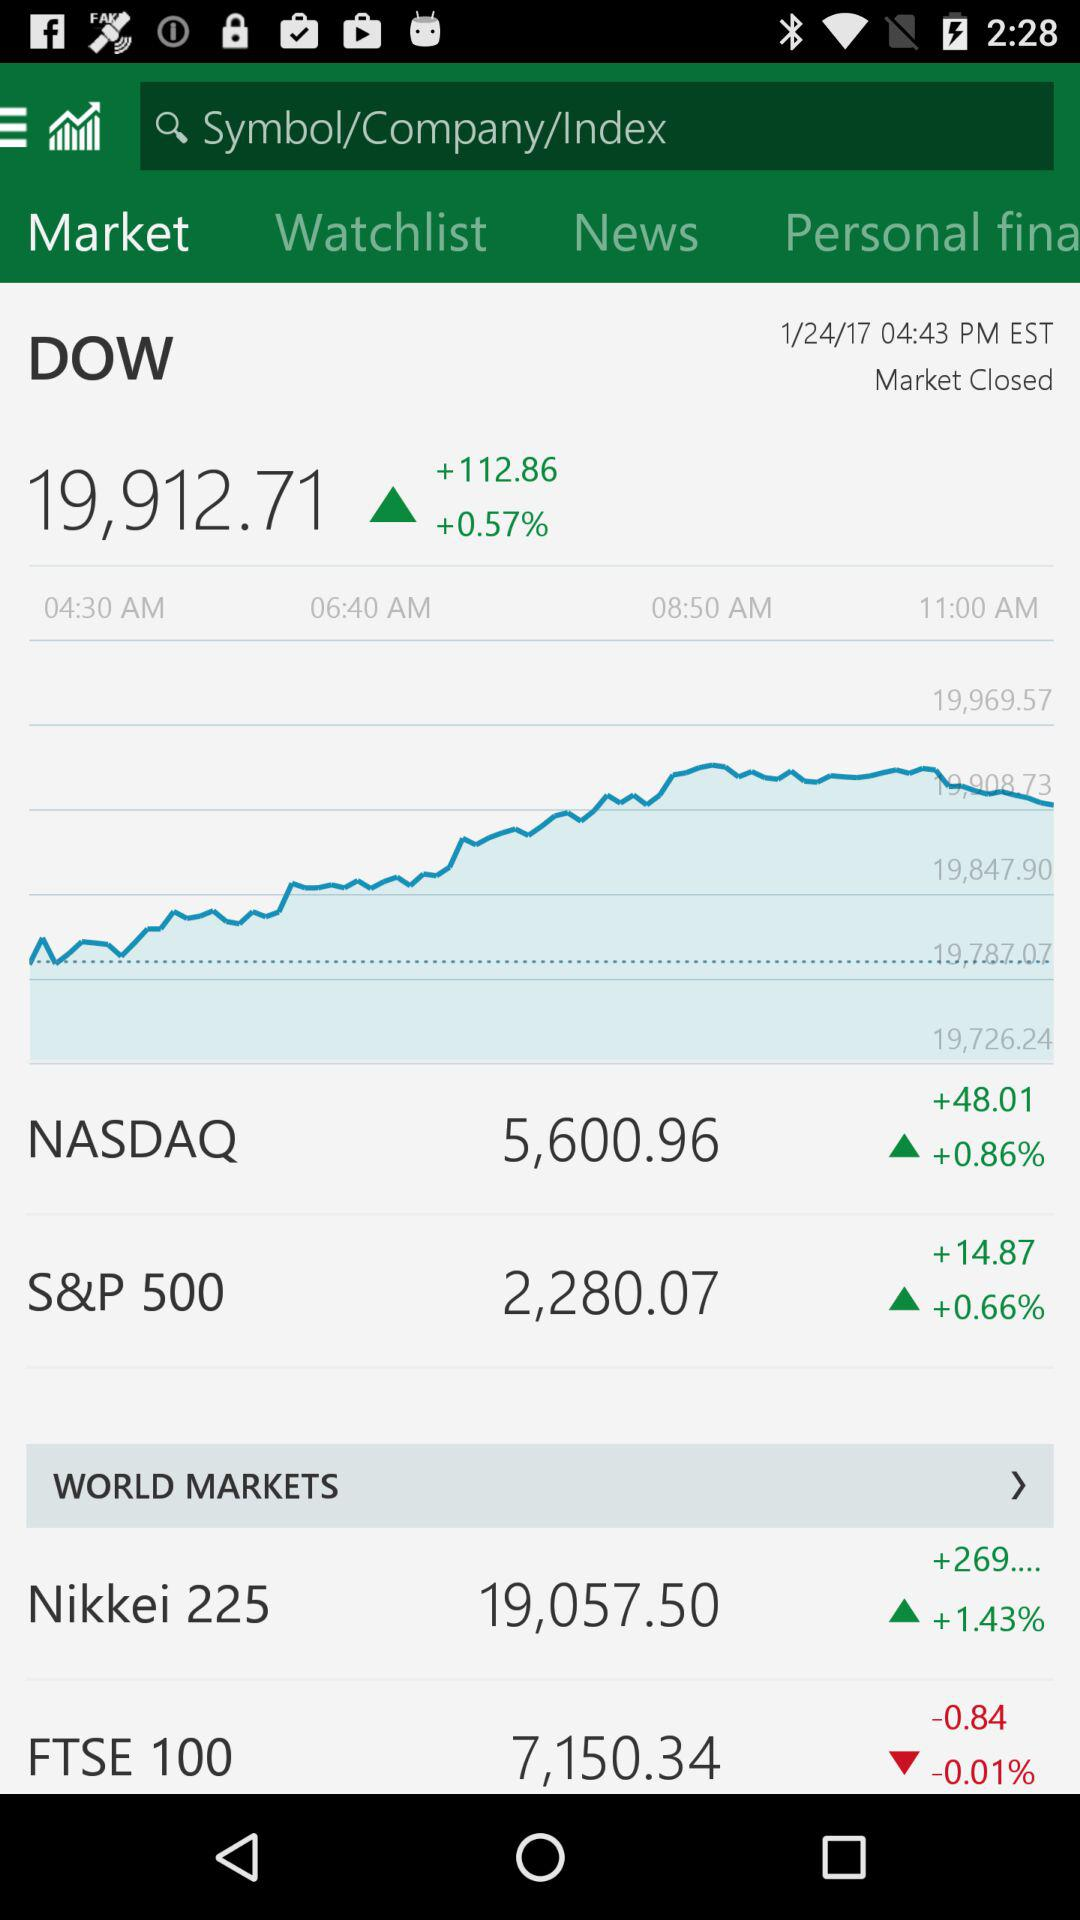How much is the S&P 500 up today?
Answer the question using a single word or phrase. +0.66% 